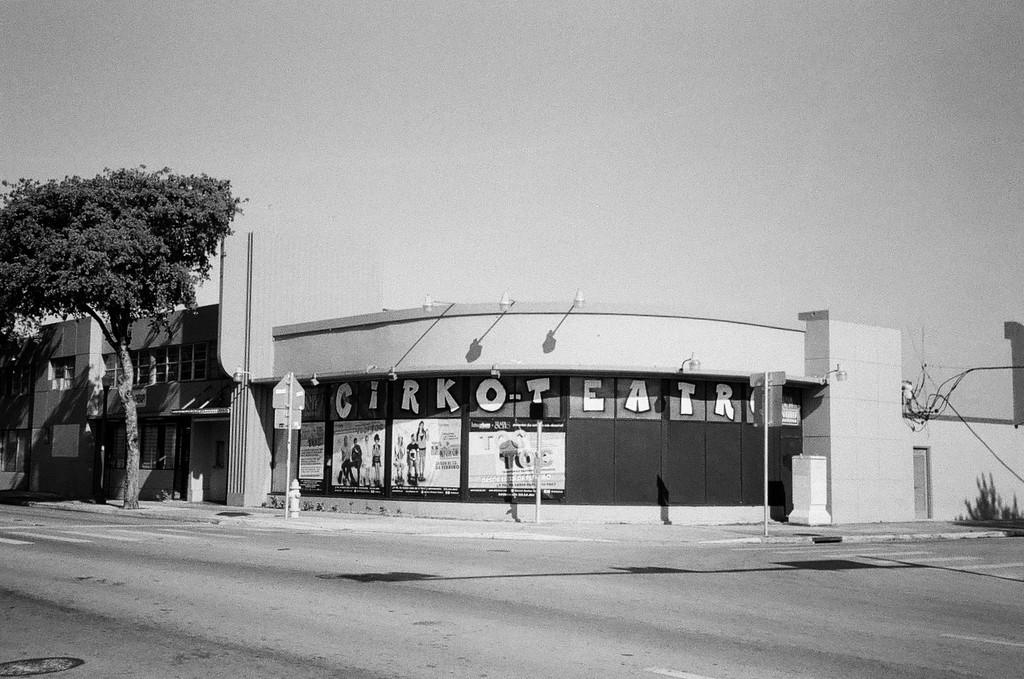What is the color scheme of the image? The image is in black and white. What is the main subject in the center of the image? There is a building with some text in the center of the image. What is located in front of the building? There is a road before the building. What type of vegetation can be seen towards the left of the image? There is a tree towards the left of the image. What is visible at the top of the image? The sky is visible at the top of the image. Can you tell me how many ears are visible in the image? There are no ears visible in the image, as it features a building, a road, a tree, and the sky. Which direction is the building facing in the image? The image does not provide enough information to determine the direction the building is facing. 